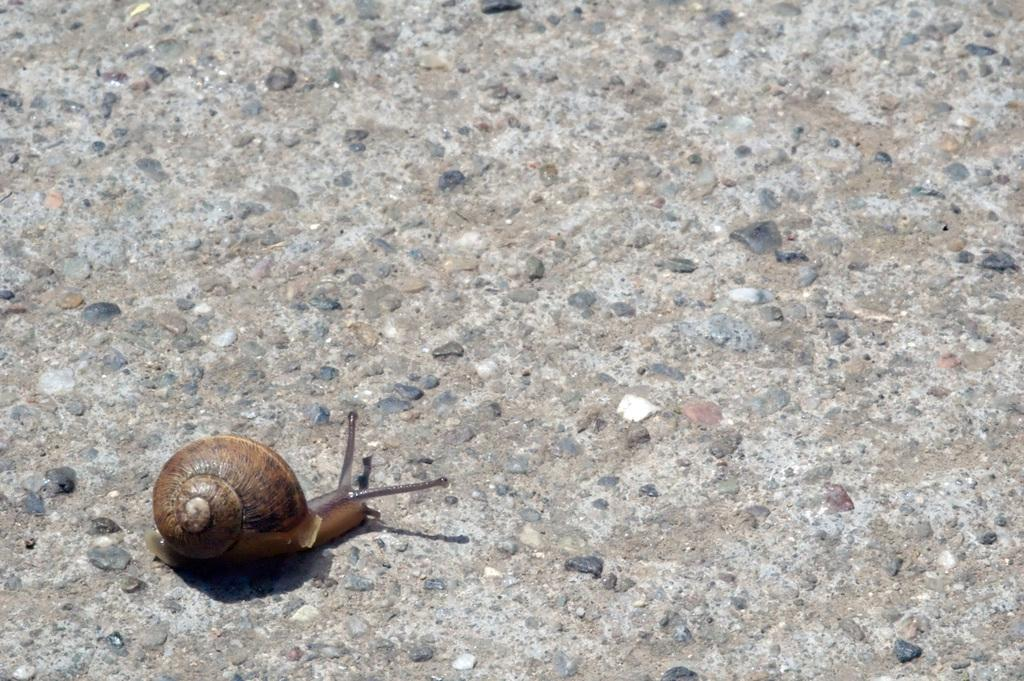What type of animal is in the image? There is a snail in the image. Where is the snail located? The snail is on the road. What type of legal advice is the snail providing in the image? There is no indication in the image that the snail is providing legal advice or that a lawyer is present. 